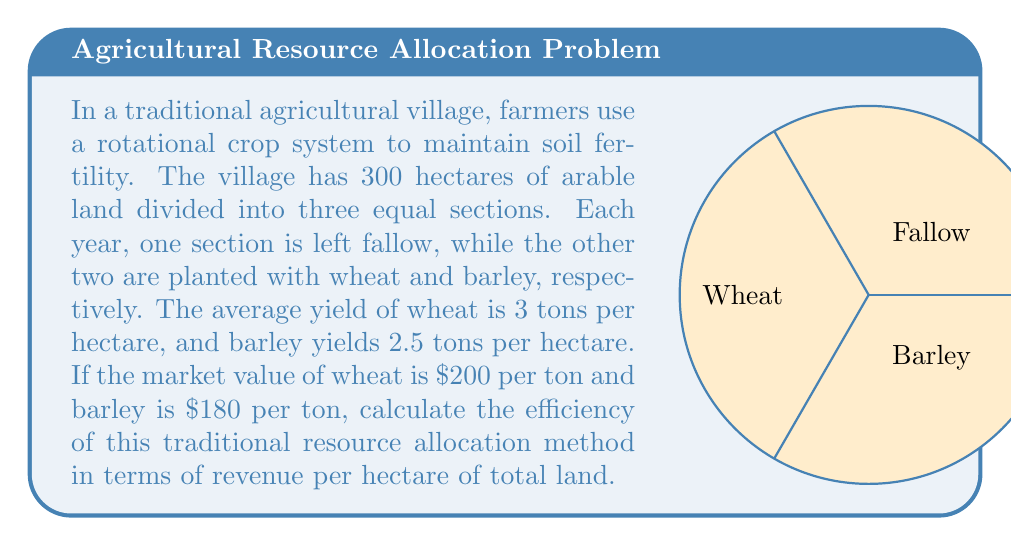What is the answer to this math problem? Let's approach this step-by-step:

1) First, calculate the total land area for each crop:
   Total land = 300 hectares
   Each section = 300 ÷ 3 = 100 hectares

2) Calculate the yield for each crop:
   Wheat: 100 hectares × 3 tons/hectare = 300 tons
   Barley: 100 hectares × 2.5 tons/hectare = 250 tons

3) Calculate the revenue for each crop:
   Wheat: 300 tons × $200/ton = $60,000
   Barley: 250 tons × $180/ton = $45,000

4) Calculate total revenue:
   Total revenue = $60,000 + $45,000 = $105,000

5) Calculate efficiency as revenue per hectare of total land:
   Efficiency = Total revenue ÷ Total land
   $$\text{Efficiency} = \frac{\$105,000}{300 \text{ hectares}} = \$350 \text{ per hectare}$$

This efficiency measure takes into account the fallow land, which is part of the traditional practice to maintain soil fertility but doesn't directly contribute to revenue in the current year.
Answer: $350 per hectare 